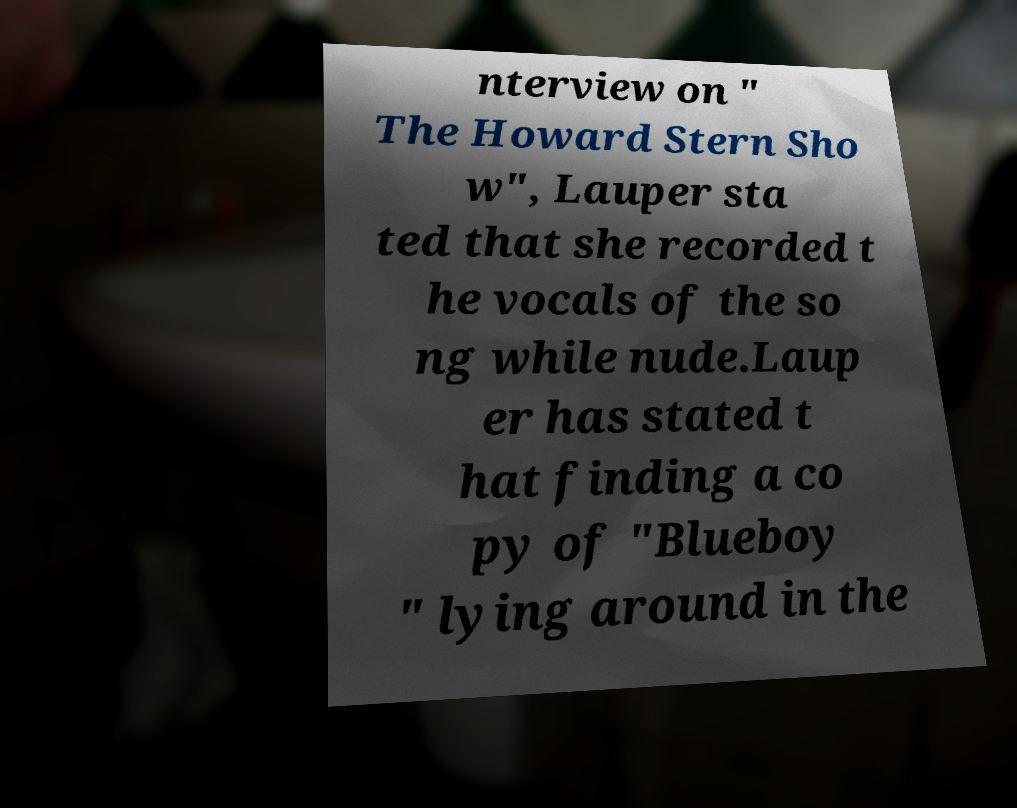Could you assist in decoding the text presented in this image and type it out clearly? nterview on " The Howard Stern Sho w", Lauper sta ted that she recorded t he vocals of the so ng while nude.Laup er has stated t hat finding a co py of "Blueboy " lying around in the 